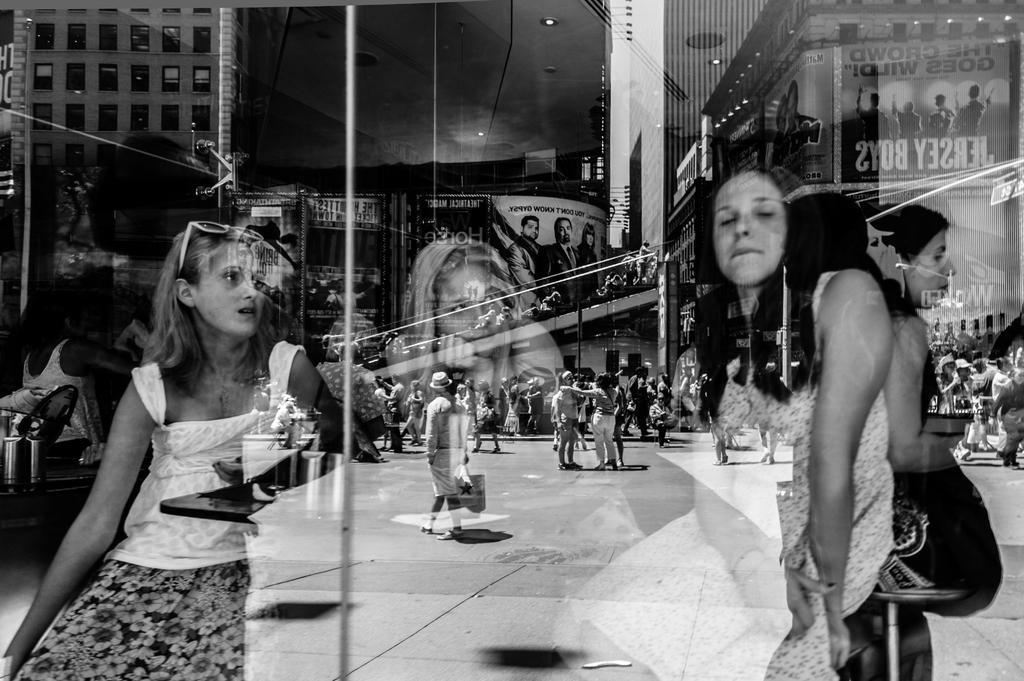Please provide a concise description of this image. In this image there are group of persons on the road, there are persons holding an object, there are women sitting, there is a table, there is a building towards the top of the image, there is roof towards the top of the image, there are lights on the roof, there are boards, there is text on the boards. 